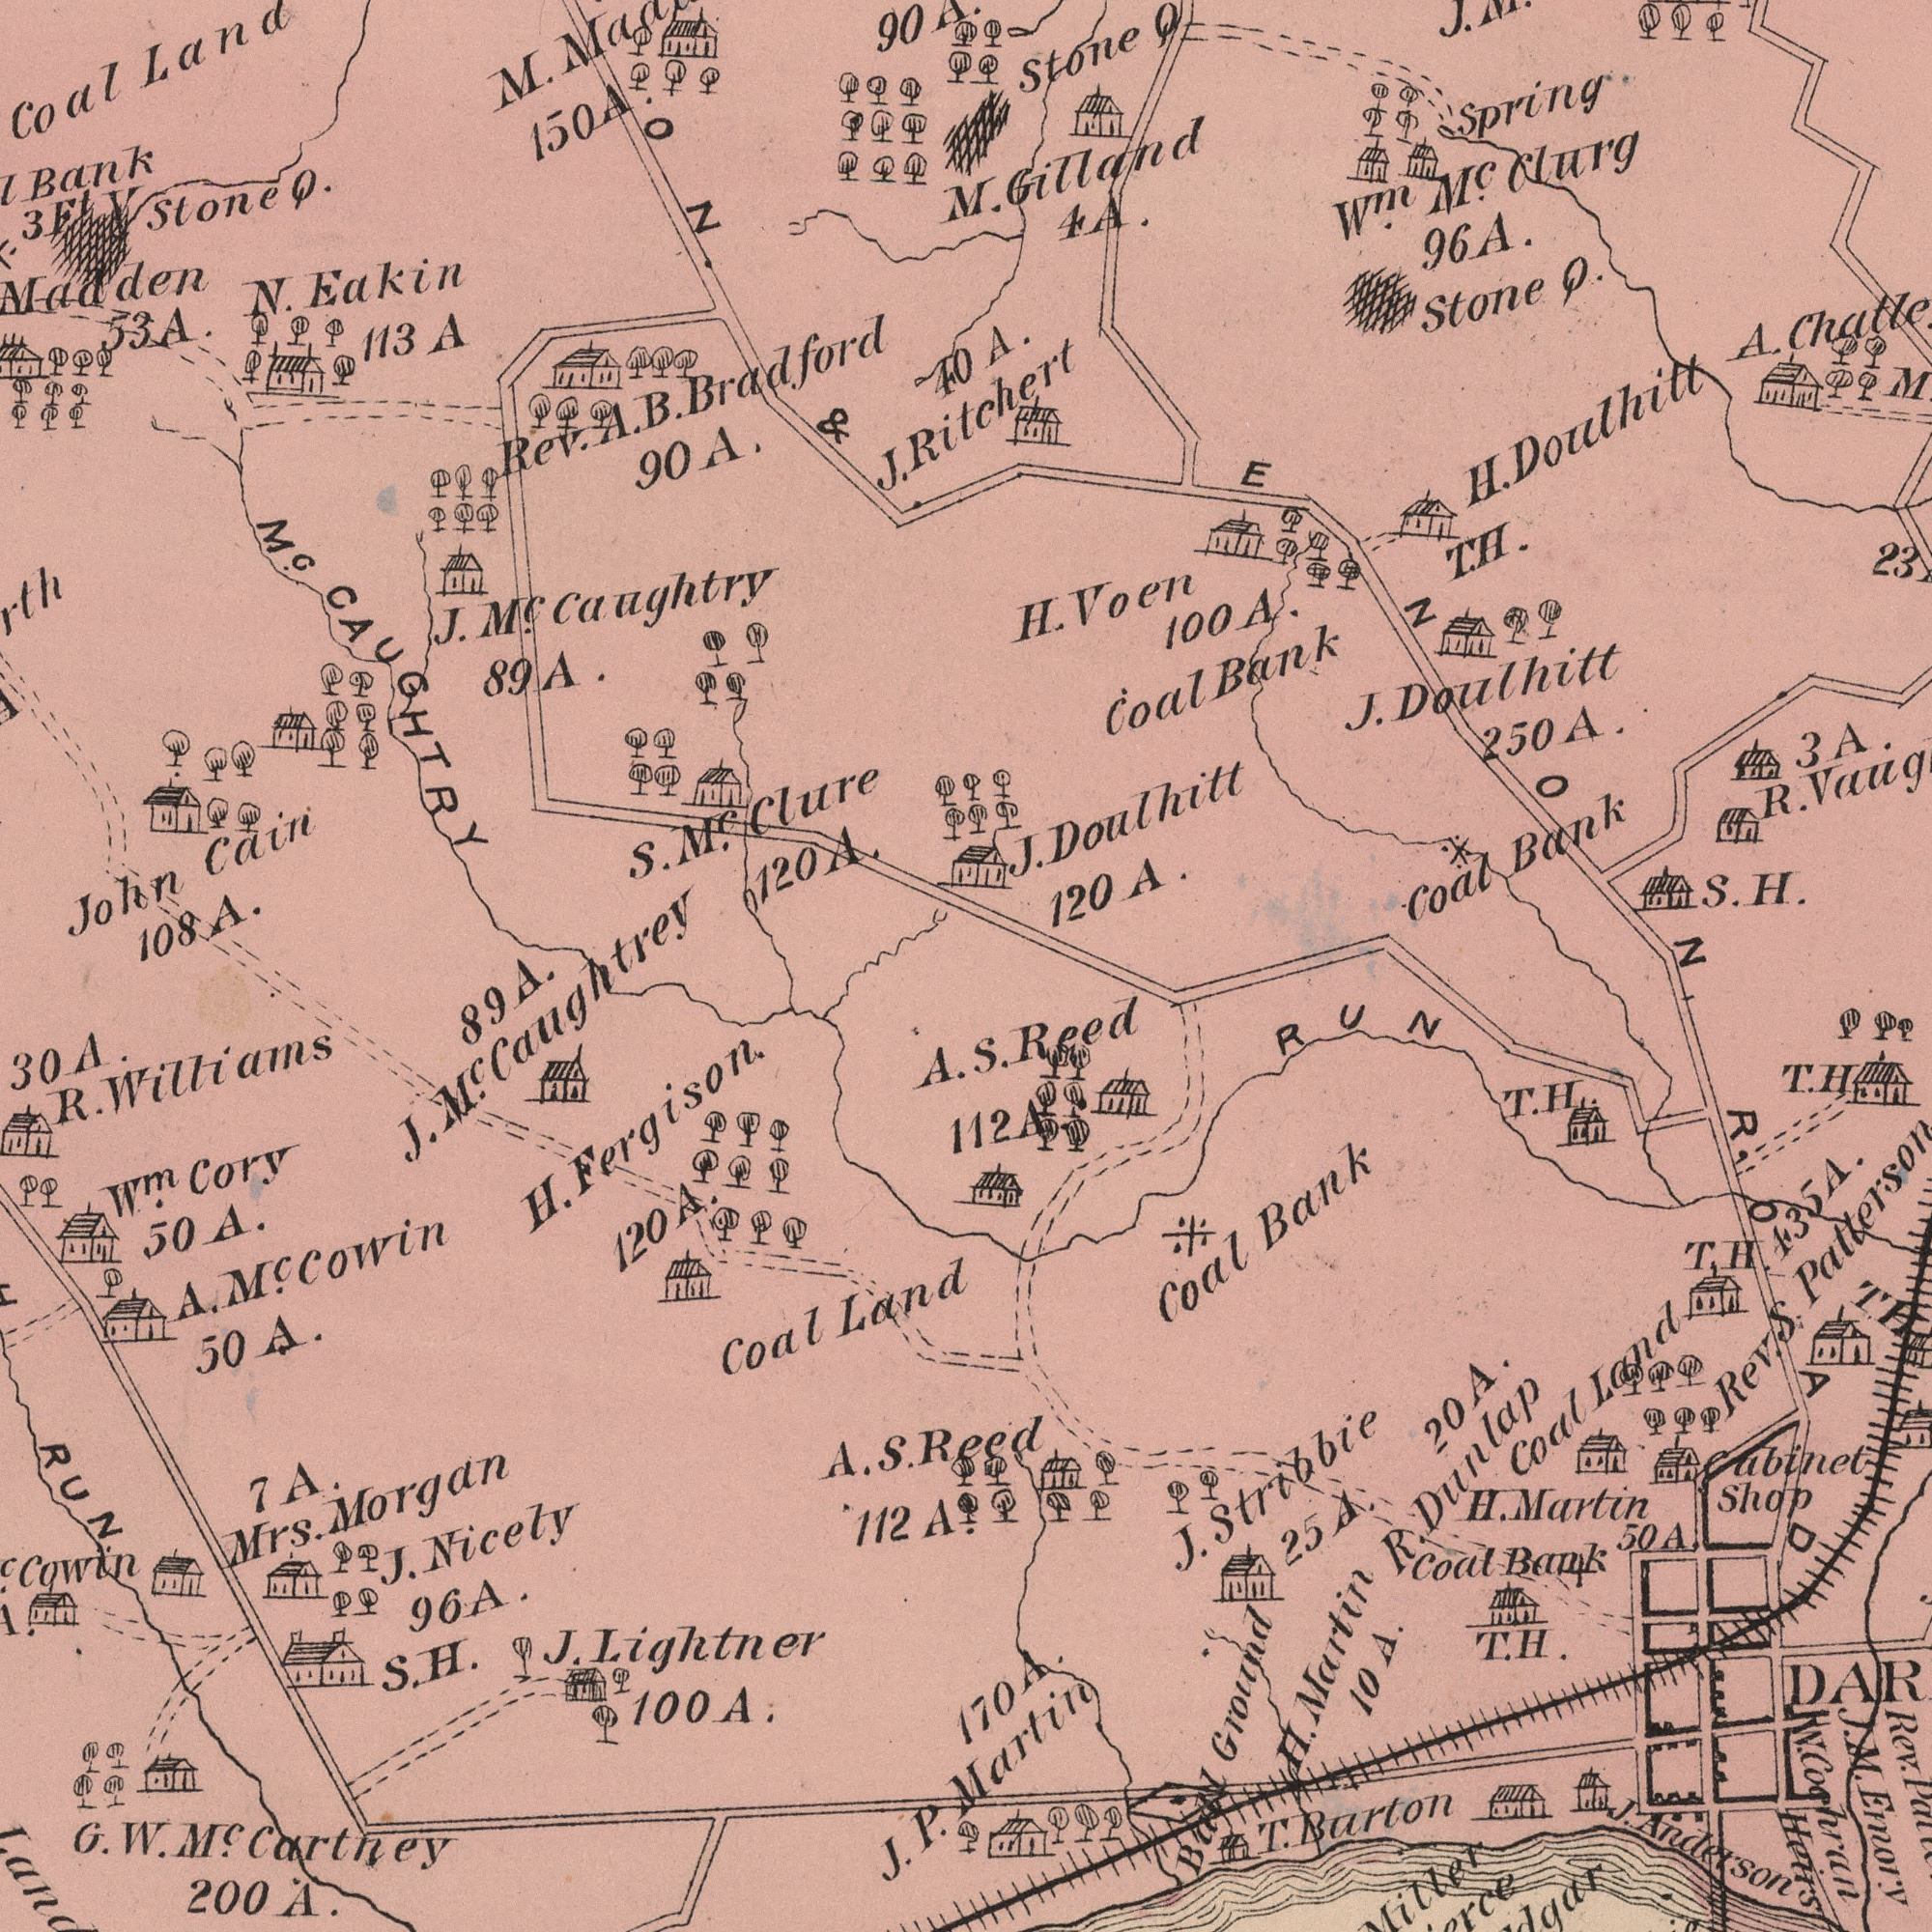What text is visible in the upper-right corner? Mc. Bank H. 96 Doulhitt Doulhitt Clurg Spring Stone J. Doulhitt J. S. Stone Wm. Coal H. 3 250 100 Bank Voen Coal H. R. Q M. Gilland 4 J. Q. A. T. H. ENON Ritchert 23 120 A. A. A. A. A. A. A. What text can you see in the bottom-right section? Bank Martin Coal Reed 170 Shop RUN Coal Rev. 50 T. R. Coal Anderson Bank 20 Heirs Martin Martin Rev. 10 J. Ground Cabinet Land Stribbie Ball H. Cochran H. Emory Dunlap Barton T. 435 Reed S. J. R. OAD 112 T. H. T. H. T. H. T. S. J. 25 H. M. W. A. A. A. A. A. A. A. What text appears in the top-left area of the image? 108 Coal 120 Caughtry John N. Mc. Mc. 90 Cain Clure Eakin 113 Land J. Mc. Bradford S. 89 & 53 stone A. Rev. CAUGHTRY 90 ###Bank 3 M. 150 Q. ###ON. 40 J. B. Ft Y A. A. A A. A. A. A. What text is visible in the lower-left corner? Fergison. Lightner A. Morgan 96 Nicely 200 H. J. Cory A. 30 Land A. Wm. Coal Mrs. Cowin Cartney G. 100 J. 112 120 J. R. Williams 89 J. Mc. Caughtrey 50 Mc. Cowin 50 RUN 7 S. H. S. P. W. Mc. A. A. A. A. A. A. A. A. A. A. 